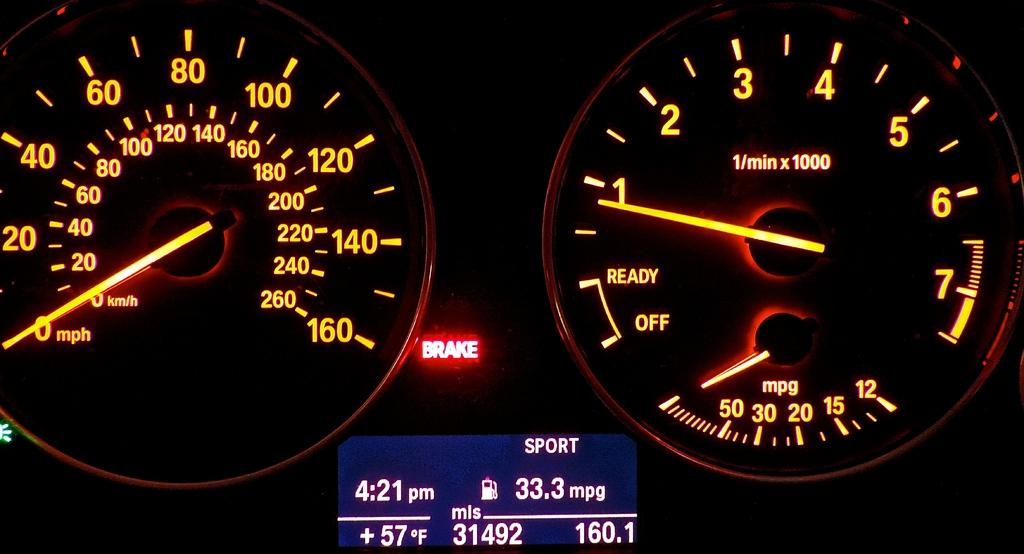<image>
Provide a brief description of the given image. Dashboard which shows the time at 4:21PM on it. 